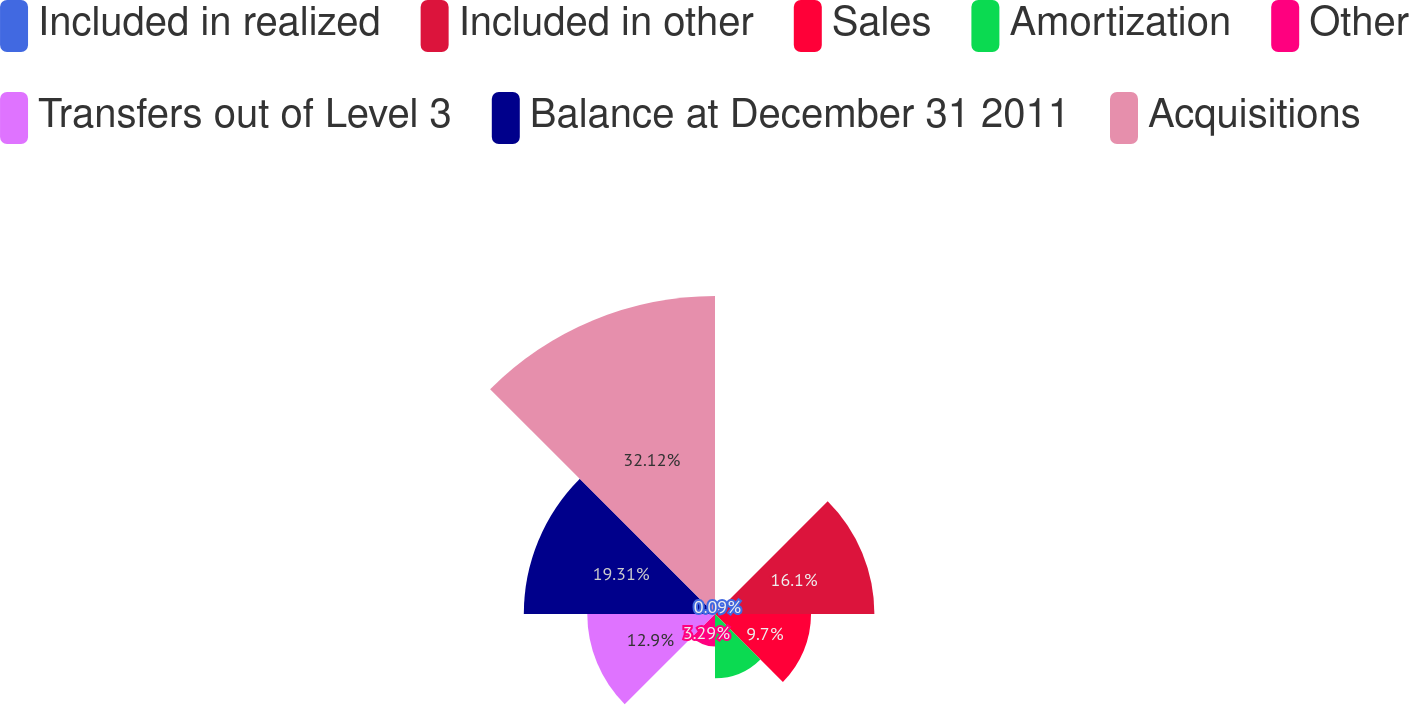Convert chart to OTSL. <chart><loc_0><loc_0><loc_500><loc_500><pie_chart><fcel>Included in realized<fcel>Included in other<fcel>Sales<fcel>Amortization<fcel>Other<fcel>Transfers out of Level 3<fcel>Balance at December 31 2011<fcel>Acquisitions<nl><fcel>0.09%<fcel>16.1%<fcel>9.7%<fcel>6.49%<fcel>3.29%<fcel>12.9%<fcel>19.31%<fcel>32.12%<nl></chart> 